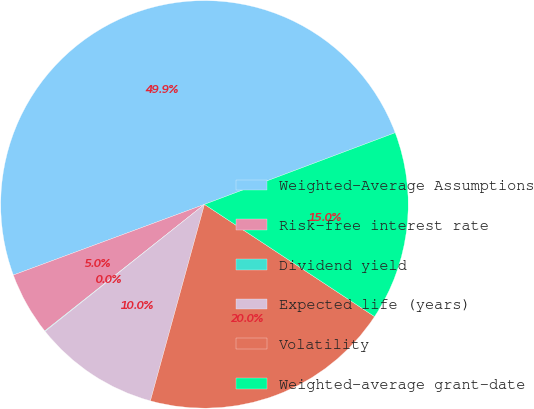Convert chart to OTSL. <chart><loc_0><loc_0><loc_500><loc_500><pie_chart><fcel>Weighted-Average Assumptions<fcel>Risk-free interest rate<fcel>Dividend yield<fcel>Expected life (years)<fcel>Volatility<fcel>Weighted-average grant-date<nl><fcel>49.91%<fcel>5.03%<fcel>0.04%<fcel>10.02%<fcel>19.99%<fcel>15.0%<nl></chart> 